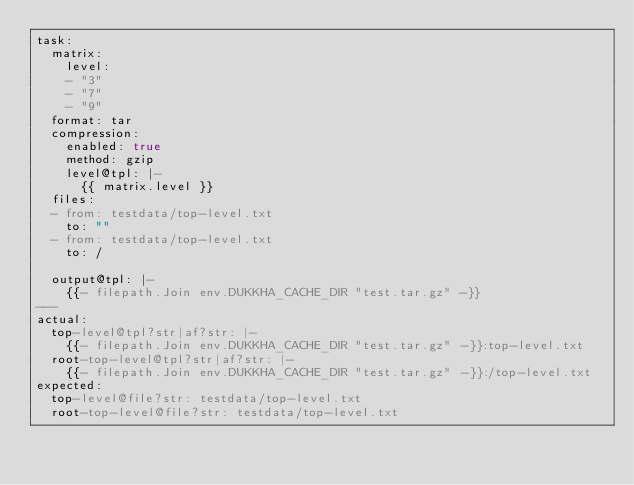Convert code to text. <code><loc_0><loc_0><loc_500><loc_500><_YAML_>task:
  matrix:
    level:
    - "3"
    - "7"
    - "9"
  format: tar
  compression:
    enabled: true
    method: gzip
    level@tpl: |-
      {{ matrix.level }}
  files:
  - from: testdata/top-level.txt
    to: ""
  - from: testdata/top-level.txt
    to: /

  output@tpl: |-
    {{- filepath.Join env.DUKKHA_CACHE_DIR "test.tar.gz" -}}
---
actual:
  top-level@tpl?str|af?str: |-
    {{- filepath.Join env.DUKKHA_CACHE_DIR "test.tar.gz" -}}:top-level.txt
  root-top-level@tpl?str|af?str: |-
    {{- filepath.Join env.DUKKHA_CACHE_DIR "test.tar.gz" -}}:/top-level.txt
expected:
  top-level@file?str: testdata/top-level.txt
  root-top-level@file?str: testdata/top-level.txt
</code> 